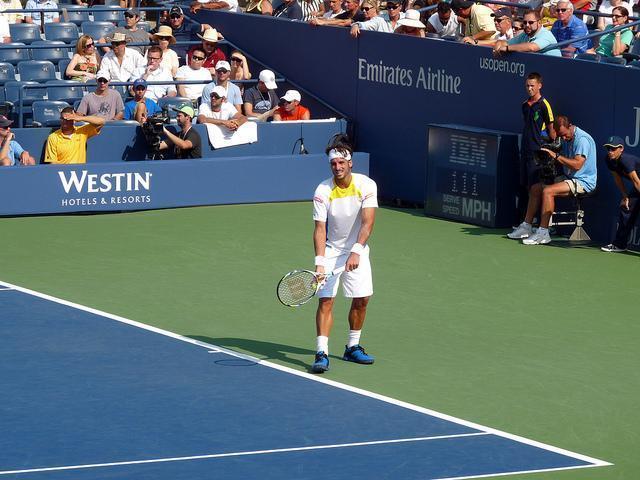How many people are in the picture?
Give a very brief answer. 6. How many dogs are following the horse?
Give a very brief answer. 0. 